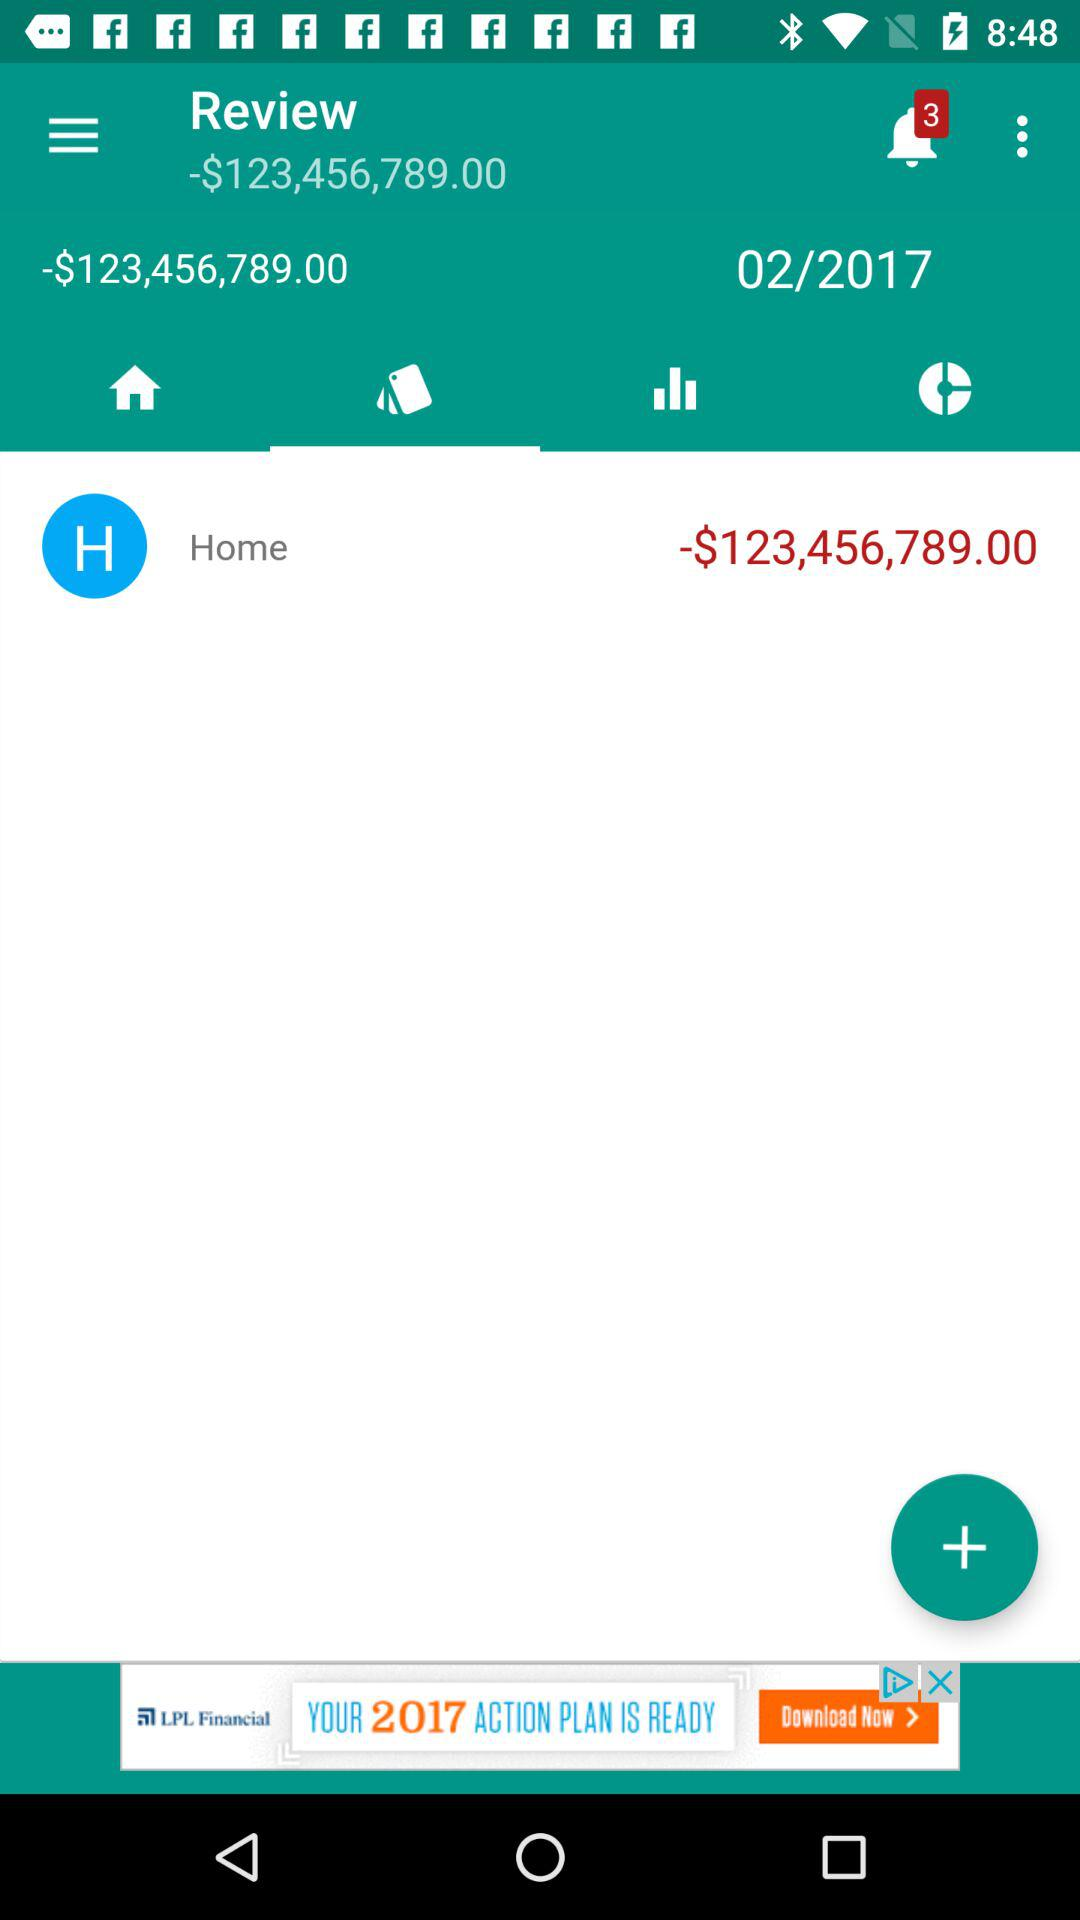What is the price?
When the provided information is insufficient, respond with <no answer>. <no answer> 